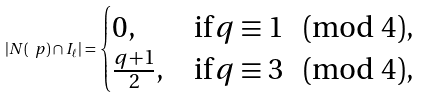<formula> <loc_0><loc_0><loc_500><loc_500>| N ( \ p ) \cap I _ { \ell } | = \begin{cases} 0 , & \text {if} \, q \equiv 1 \pmod { 4 } , \\ \frac { q + 1 } { 2 } , & \text {if} \, q \equiv 3 \pmod { 4 } , \end{cases}</formula> 